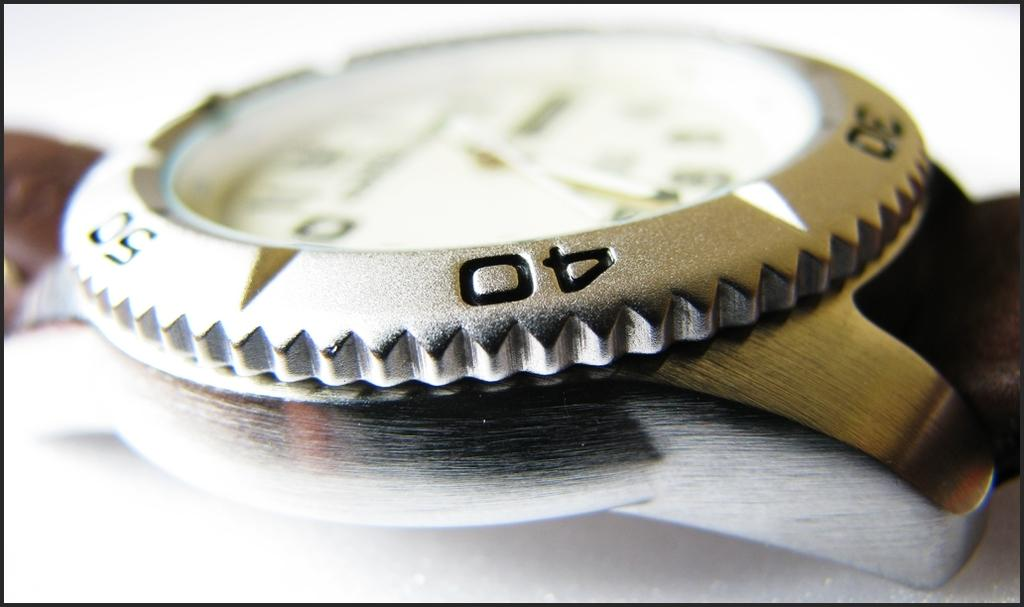<image>
Summarize the visual content of the image. The numbers 30 40 and 50 are visible on the silver watch bezel. 